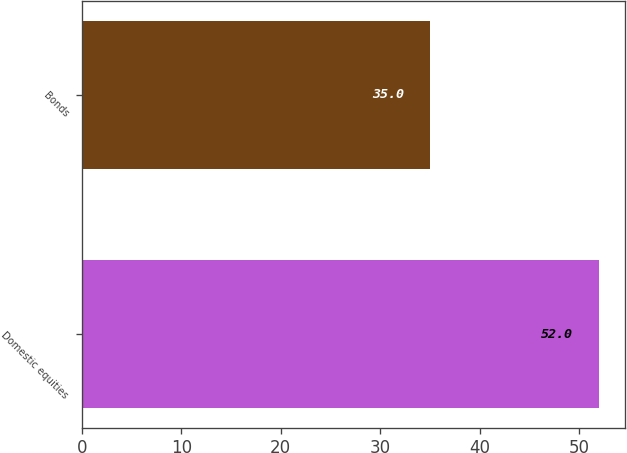Convert chart to OTSL. <chart><loc_0><loc_0><loc_500><loc_500><bar_chart><fcel>Domestic equities<fcel>Bonds<nl><fcel>52<fcel>35<nl></chart> 